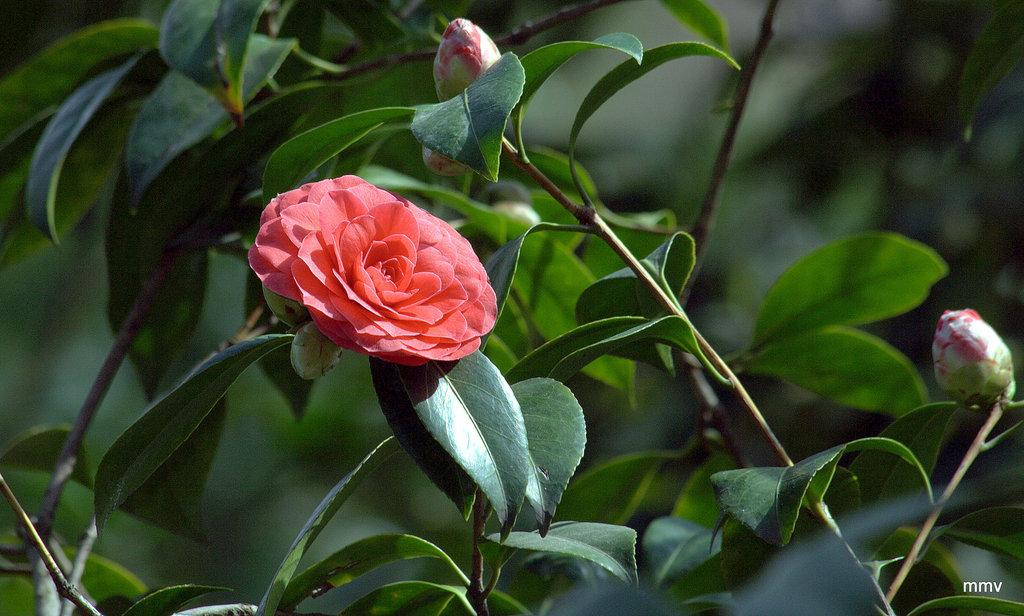What type of plants can be seen in the image? There are flower plants in the image. What is the color of the flower? The flower is red in color. How would you describe the background of the image? The background of the image is blurred. Is there any additional information or marking on the image? Yes, there is a watermark on the bottom right side of the image. What grade did the flower receive in the image? There is no indication of a grade or evaluation in the image; it simply shows a red flower and flower plants. 